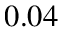<formula> <loc_0><loc_0><loc_500><loc_500>0 . 0 4</formula> 